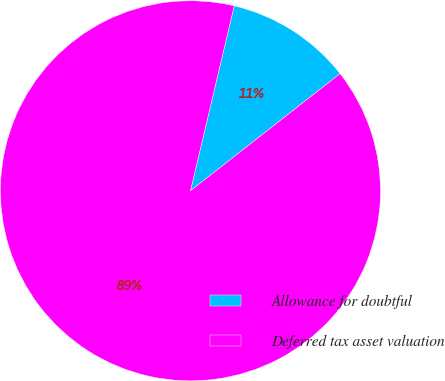Convert chart to OTSL. <chart><loc_0><loc_0><loc_500><loc_500><pie_chart><fcel>Allowance for doubtful<fcel>Deferred tax asset valuation<nl><fcel>10.73%<fcel>89.27%<nl></chart> 